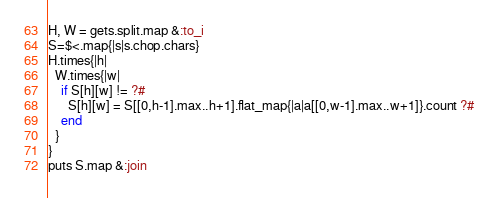<code> <loc_0><loc_0><loc_500><loc_500><_Ruby_>H, W = gets.split.map &:to_i
S=$<.map{|s|s.chop.chars}
H.times{|h|
  W.times{|w|
    if S[h][w] != ?#
      S[h][w] = S[[0,h-1].max..h+1].flat_map{|a|a[[0,w-1].max..w+1]}.count ?#
    end
  }
}
puts S.map &:join
</code> 